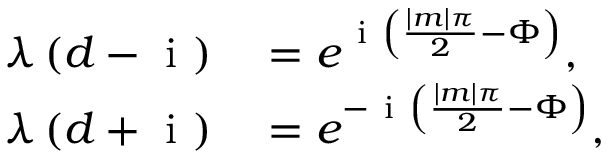Convert formula to latex. <formula><loc_0><loc_0><loc_500><loc_500>\begin{array} { r l } { \lambda \left ( d - i \right ) } & = e ^ { i \left ( \frac { | m | \pi } { 2 } - \Phi \right ) } , } \\ { \lambda \left ( d + i \right ) } & = e ^ { - i \left ( \frac { | m | \pi } { 2 } - \Phi \right ) } , } \end{array}</formula> 